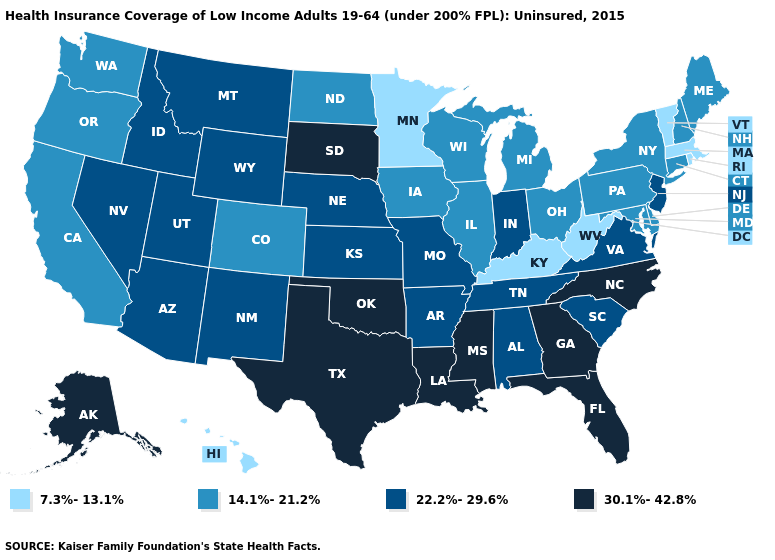What is the value of Indiana?
Answer briefly. 22.2%-29.6%. Does Illinois have a higher value than New Mexico?
Keep it brief. No. Among the states that border Idaho , which have the highest value?
Concise answer only. Montana, Nevada, Utah, Wyoming. Name the states that have a value in the range 7.3%-13.1%?
Be succinct. Hawaii, Kentucky, Massachusetts, Minnesota, Rhode Island, Vermont, West Virginia. Among the states that border Minnesota , does North Dakota have the highest value?
Answer briefly. No. Is the legend a continuous bar?
Short answer required. No. Does Hawaii have the lowest value in the West?
Short answer required. Yes. Name the states that have a value in the range 7.3%-13.1%?
Short answer required. Hawaii, Kentucky, Massachusetts, Minnesota, Rhode Island, Vermont, West Virginia. Does Rhode Island have the lowest value in the USA?
Concise answer only. Yes. Does Florida have the highest value in the USA?
Write a very short answer. Yes. Which states have the lowest value in the USA?
Short answer required. Hawaii, Kentucky, Massachusetts, Minnesota, Rhode Island, Vermont, West Virginia. Name the states that have a value in the range 22.2%-29.6%?
Answer briefly. Alabama, Arizona, Arkansas, Idaho, Indiana, Kansas, Missouri, Montana, Nebraska, Nevada, New Jersey, New Mexico, South Carolina, Tennessee, Utah, Virginia, Wyoming. Name the states that have a value in the range 22.2%-29.6%?
Give a very brief answer. Alabama, Arizona, Arkansas, Idaho, Indiana, Kansas, Missouri, Montana, Nebraska, Nevada, New Jersey, New Mexico, South Carolina, Tennessee, Utah, Virginia, Wyoming. Name the states that have a value in the range 22.2%-29.6%?
Short answer required. Alabama, Arizona, Arkansas, Idaho, Indiana, Kansas, Missouri, Montana, Nebraska, Nevada, New Jersey, New Mexico, South Carolina, Tennessee, Utah, Virginia, Wyoming. Does Louisiana have the highest value in the USA?
Quick response, please. Yes. 